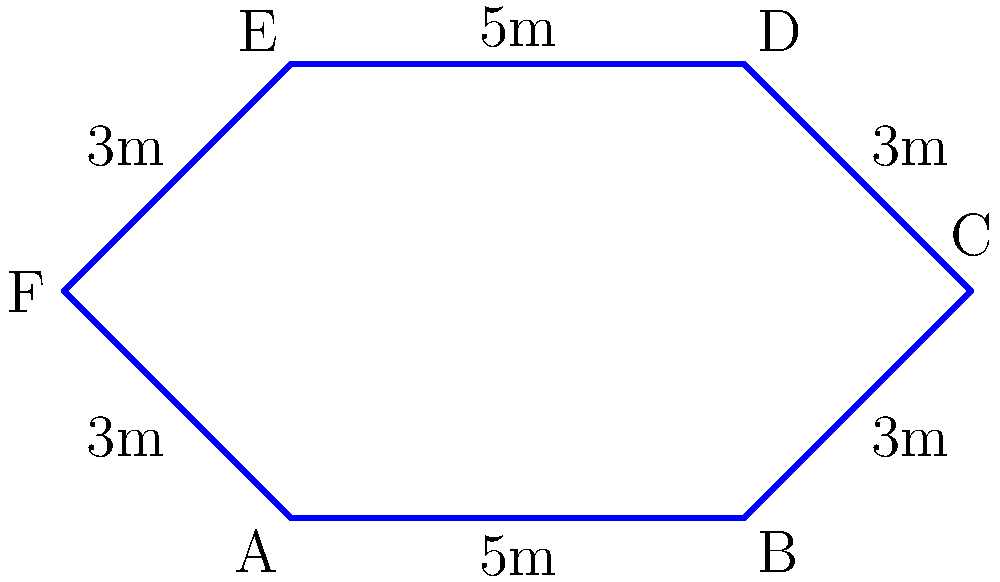Colonel, our combat engineers have designed a star-shaped fortification for our forward operating base. The fortification has six sides with alternating lengths of 5 meters and 3 meters, as shown in the diagram. Calculate the perimeter of this fortification to determine the amount of razor wire needed for its security. To calculate the perimeter of the star-shaped fortification, we need to sum up the lengths of all sides. Let's approach this step-by-step:

1) First, let's identify the lengths of each side:
   Side AB = 5m
   Side BC = 3m
   Side CD = 3m
   Side DE = 5m
   Side EF = 3m
   Side FA = 3m

2) Now, we simply add all these lengths together:
   
   Perimeter = AB + BC + CD + DE + EF + FA
              = 5m + 3m + 3m + 5m + 3m + 3m

3) Simplifying:
   Perimeter = (5m × 2) + (3m × 4)
              = 10m + 12m
              = 22m

Therefore, the perimeter of the star-shaped fortification is 22 meters.
Answer: 22 meters 